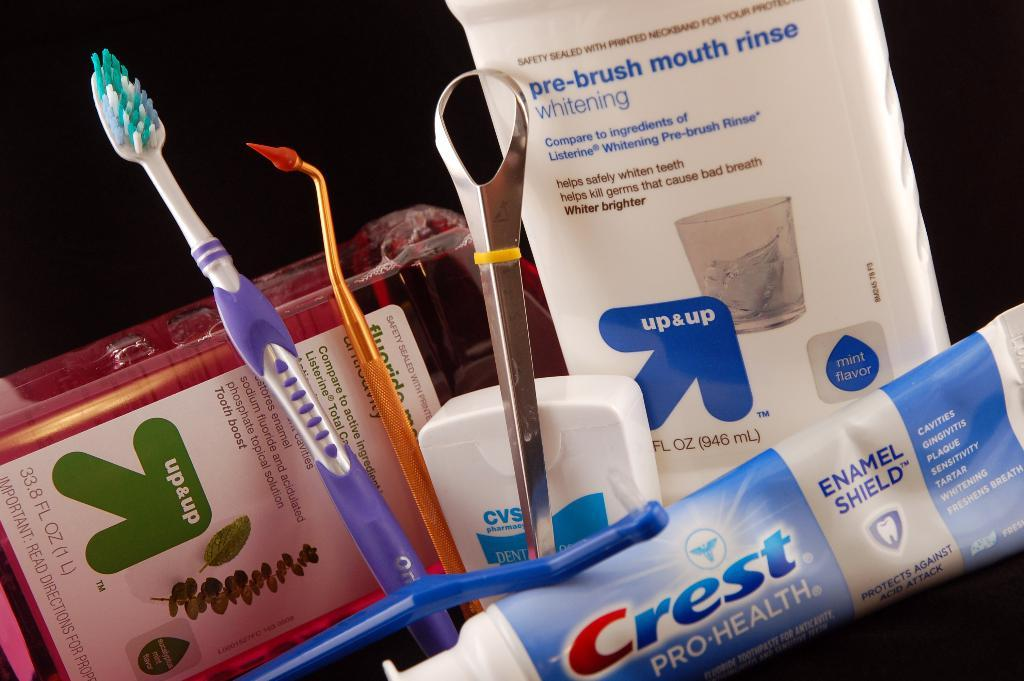<image>
Give a short and clear explanation of the subsequent image. Various dental care items are displayed including a toothbrush and a tube of crest. 